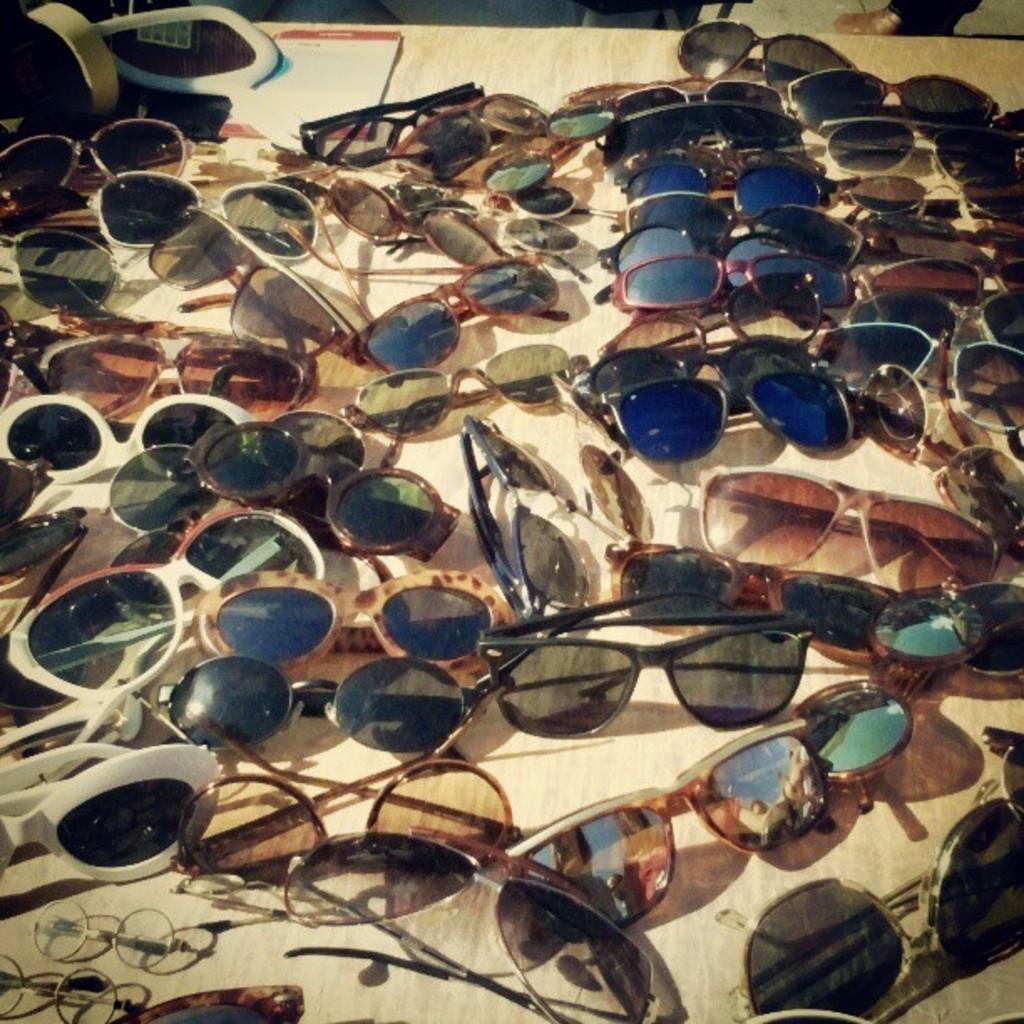Describe this image in one or two sentences. We can see goggles and objects on the table. In the background we can see person leg. 